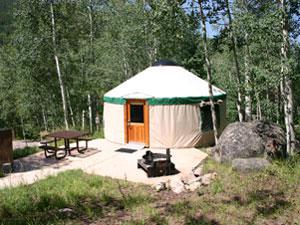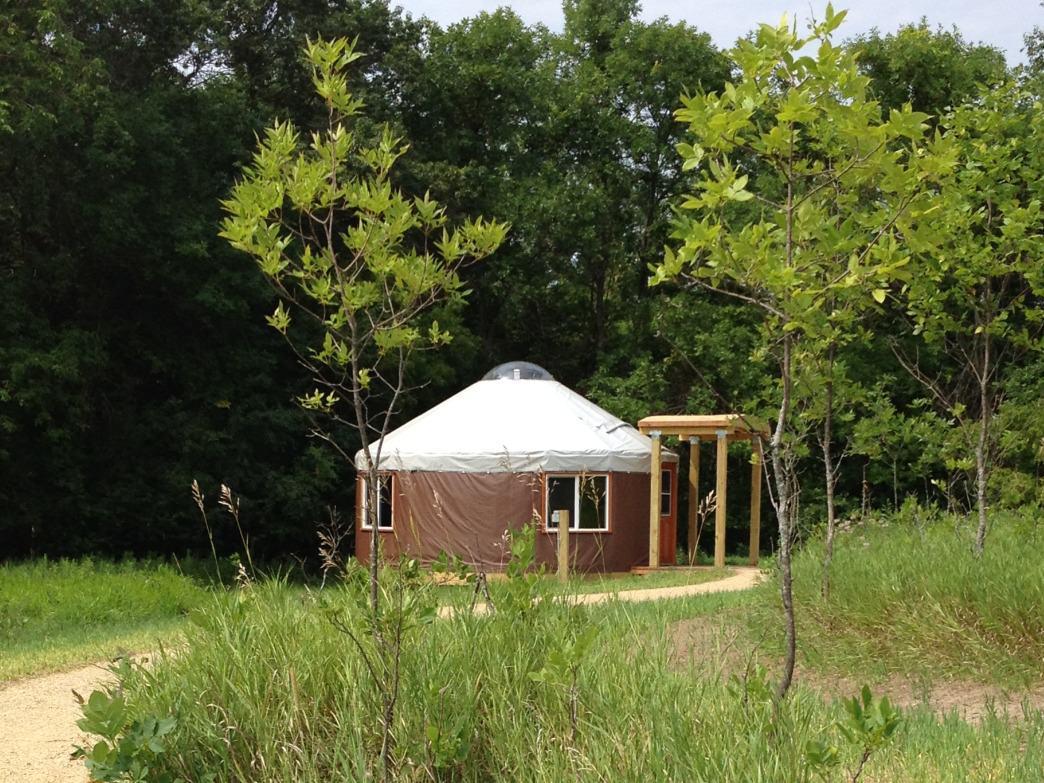The first image is the image on the left, the second image is the image on the right. Analyze the images presented: Is the assertion "There is a structure with a wooden roof to the right of the yurt in the image on the right." valid? Answer yes or no. Yes. 